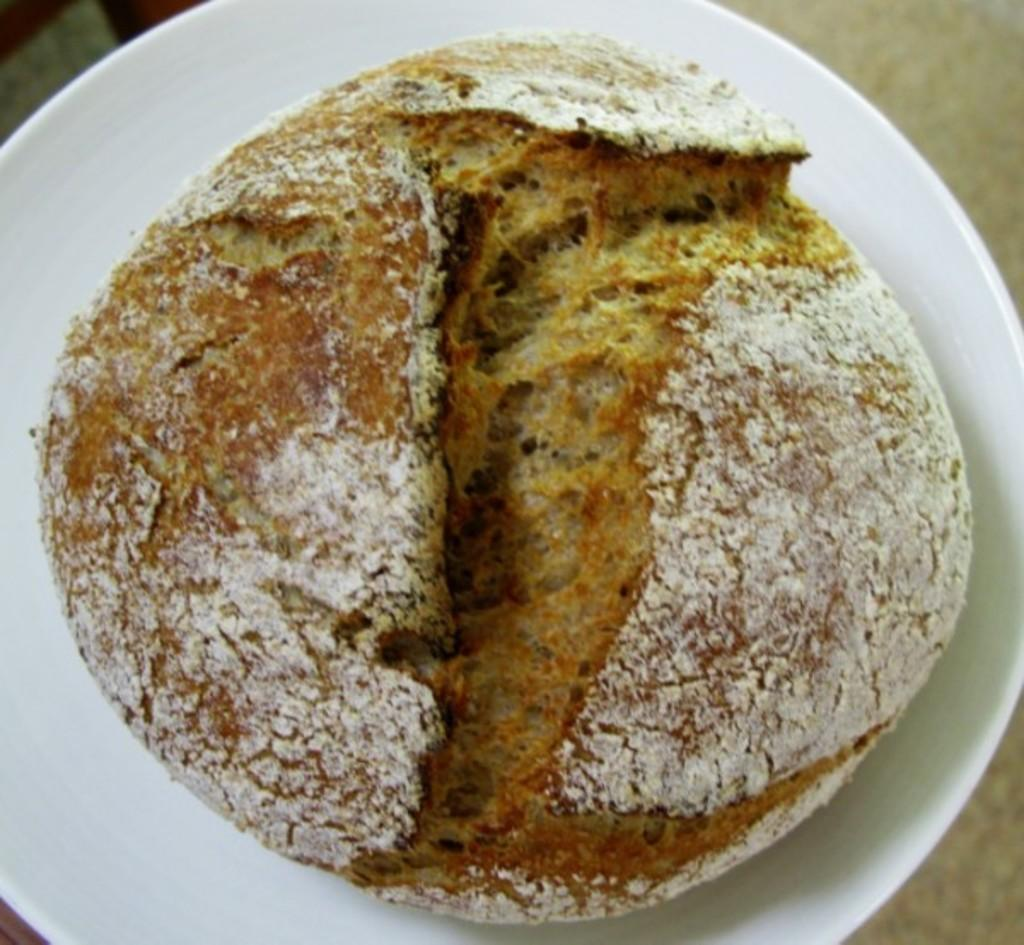What is on the plate that is visible in the image? There is an eatable item on a plate in the image. Where is the plate located in the image? The plate is placed on a surface in the image. Can you see a cat sailing a boat in the image? No, there is no cat or boat present in the image. 